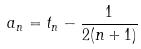<formula> <loc_0><loc_0><loc_500><loc_500>a _ { n } = t _ { n } - \frac { 1 } { 2 ( n + 1 ) }</formula> 